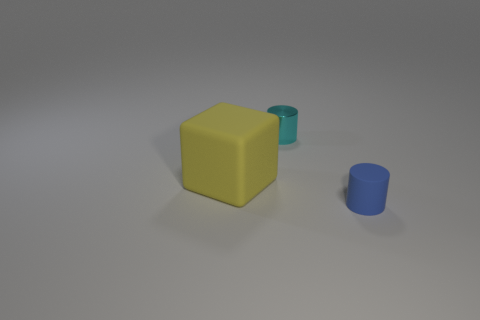Add 3 tiny cyan shiny spheres. How many objects exist? 6 Add 2 small blue rubber objects. How many small blue rubber objects are left? 3 Add 2 metal objects. How many metal objects exist? 3 Subtract 1 cyan cylinders. How many objects are left? 2 Subtract all cubes. How many objects are left? 2 Subtract all gray blocks. Subtract all gray cylinders. How many blocks are left? 1 Subtract all large gray cubes. Subtract all yellow objects. How many objects are left? 2 